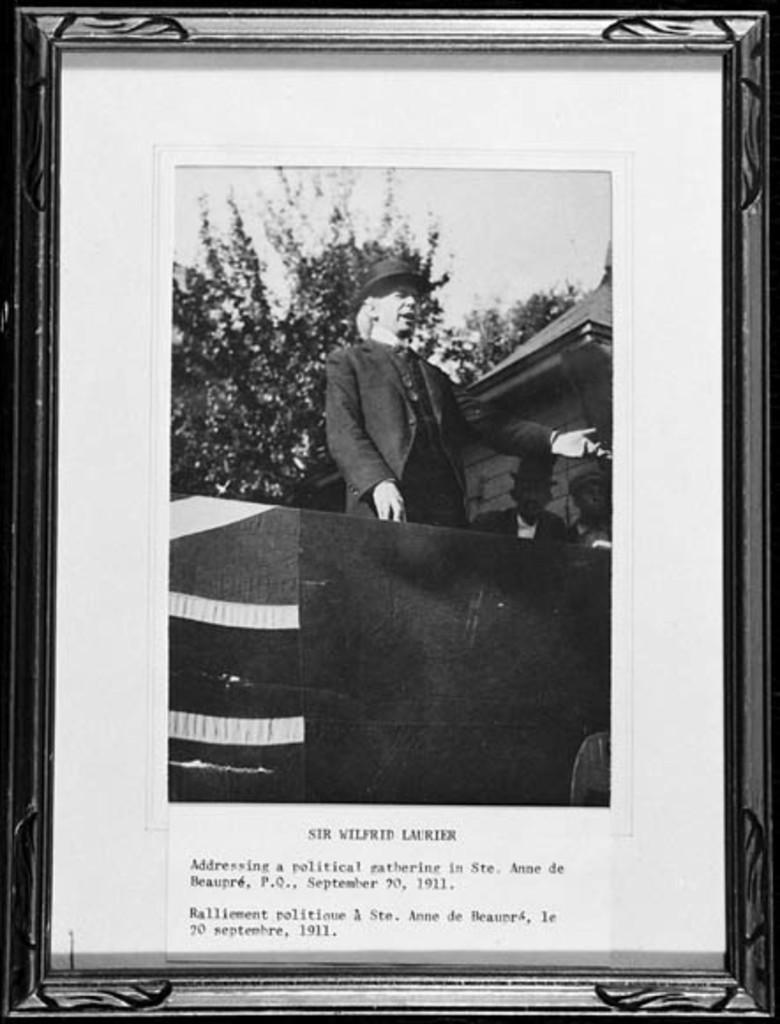<image>
Write a terse but informative summary of the picture. A framed black and white picture of Sir Wilfrid Lauriex. 